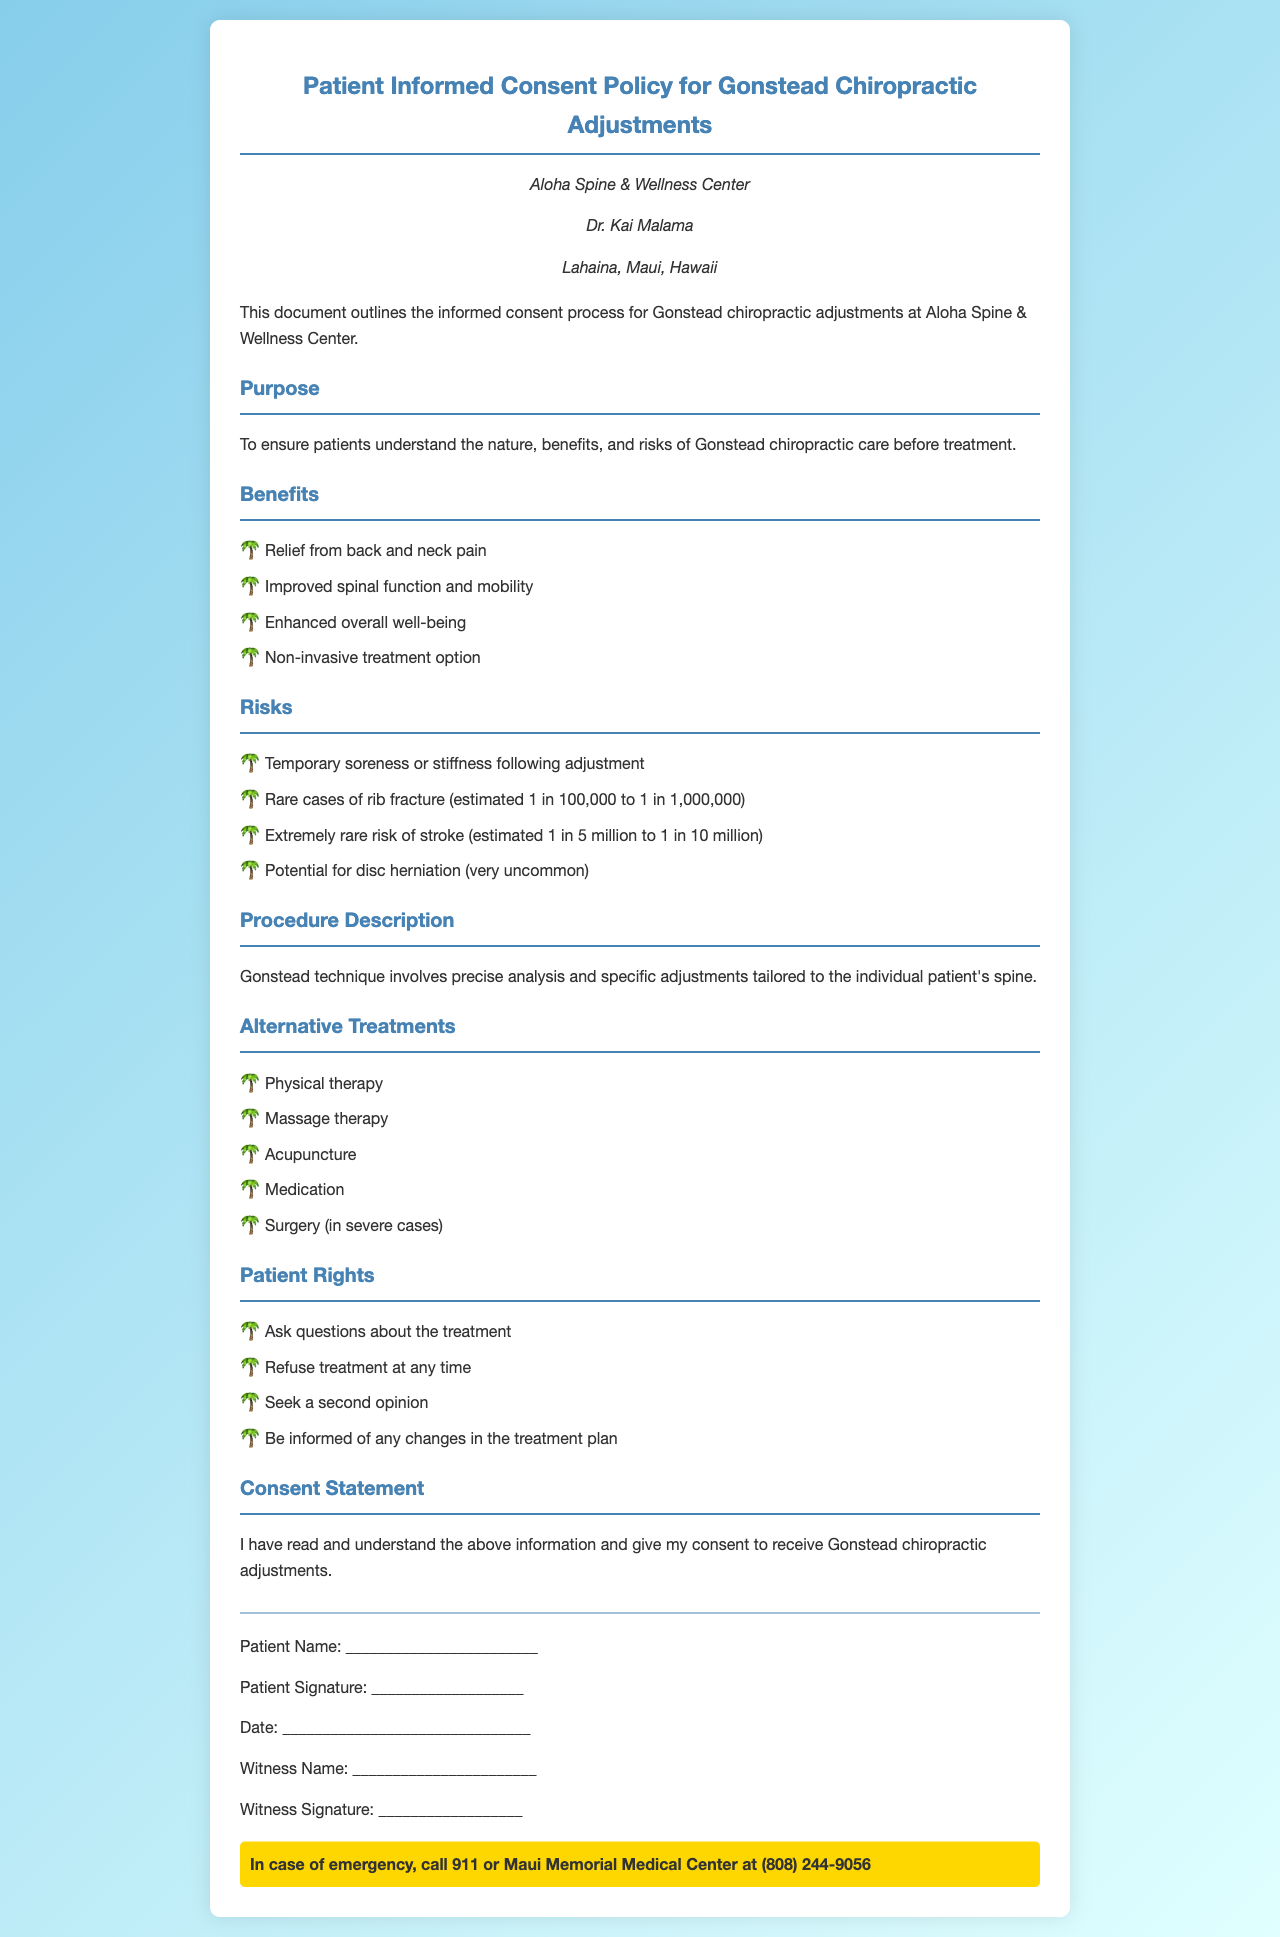what is the name of the clinic? The clinic's name is mentioned prominently at the top of the document.
Answer: Aloha Spine & Wellness Center who is the chiropractor named in the document? The document contains the name of the chiropractor in the clinic information section.
Answer: Dr. Kai Malama what are the estimated rare cases of stroke risk? The document specifies the estimated risk numbers in the section on risks.
Answer: 1 in 5 million to 1 in 10 million what is one benefit of Gonstead chiropractic adjustments? The document lists several benefits under the benefits section.
Answer: Relief from back and neck pain what rights do patients have according to the policy? The document provides a list of patient rights which are highlighted in a specific section.
Answer: Ask questions about the treatment what is the purpose of this policy document? The purpose is stated near the beginning of the document, outlining its intent.
Answer: To ensure patients understand the nature, benefits, and risks of Gonstead chiropractic care before treatment what is one alternative treatment mentioned in the document? The document includes a section listing alternative treatments for patients to consider.
Answer: Physical therapy how many signature fields are present in the consent statement? The number of signature fields is clearly outlined in the signature area section of the document.
Answer: Five 